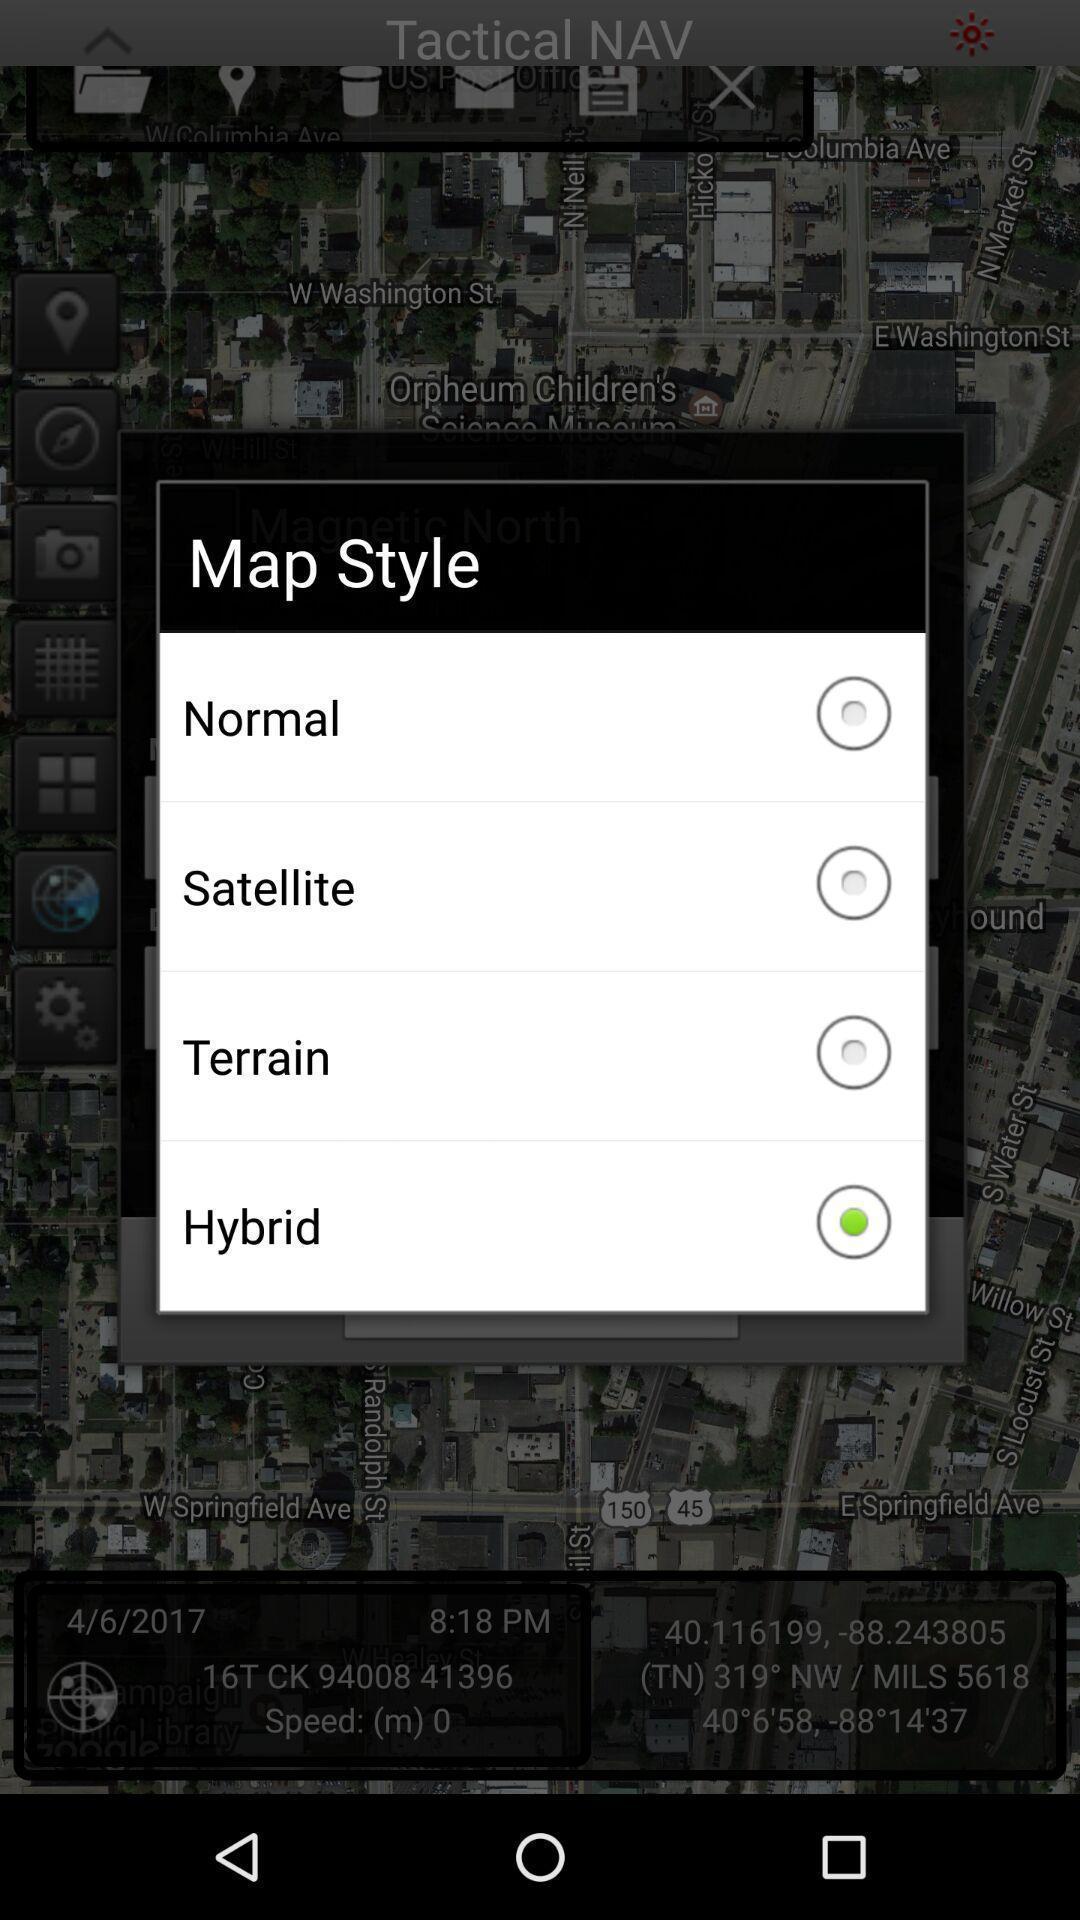Summarize the main components in this picture. Screen displaying the different styles in mapping. 